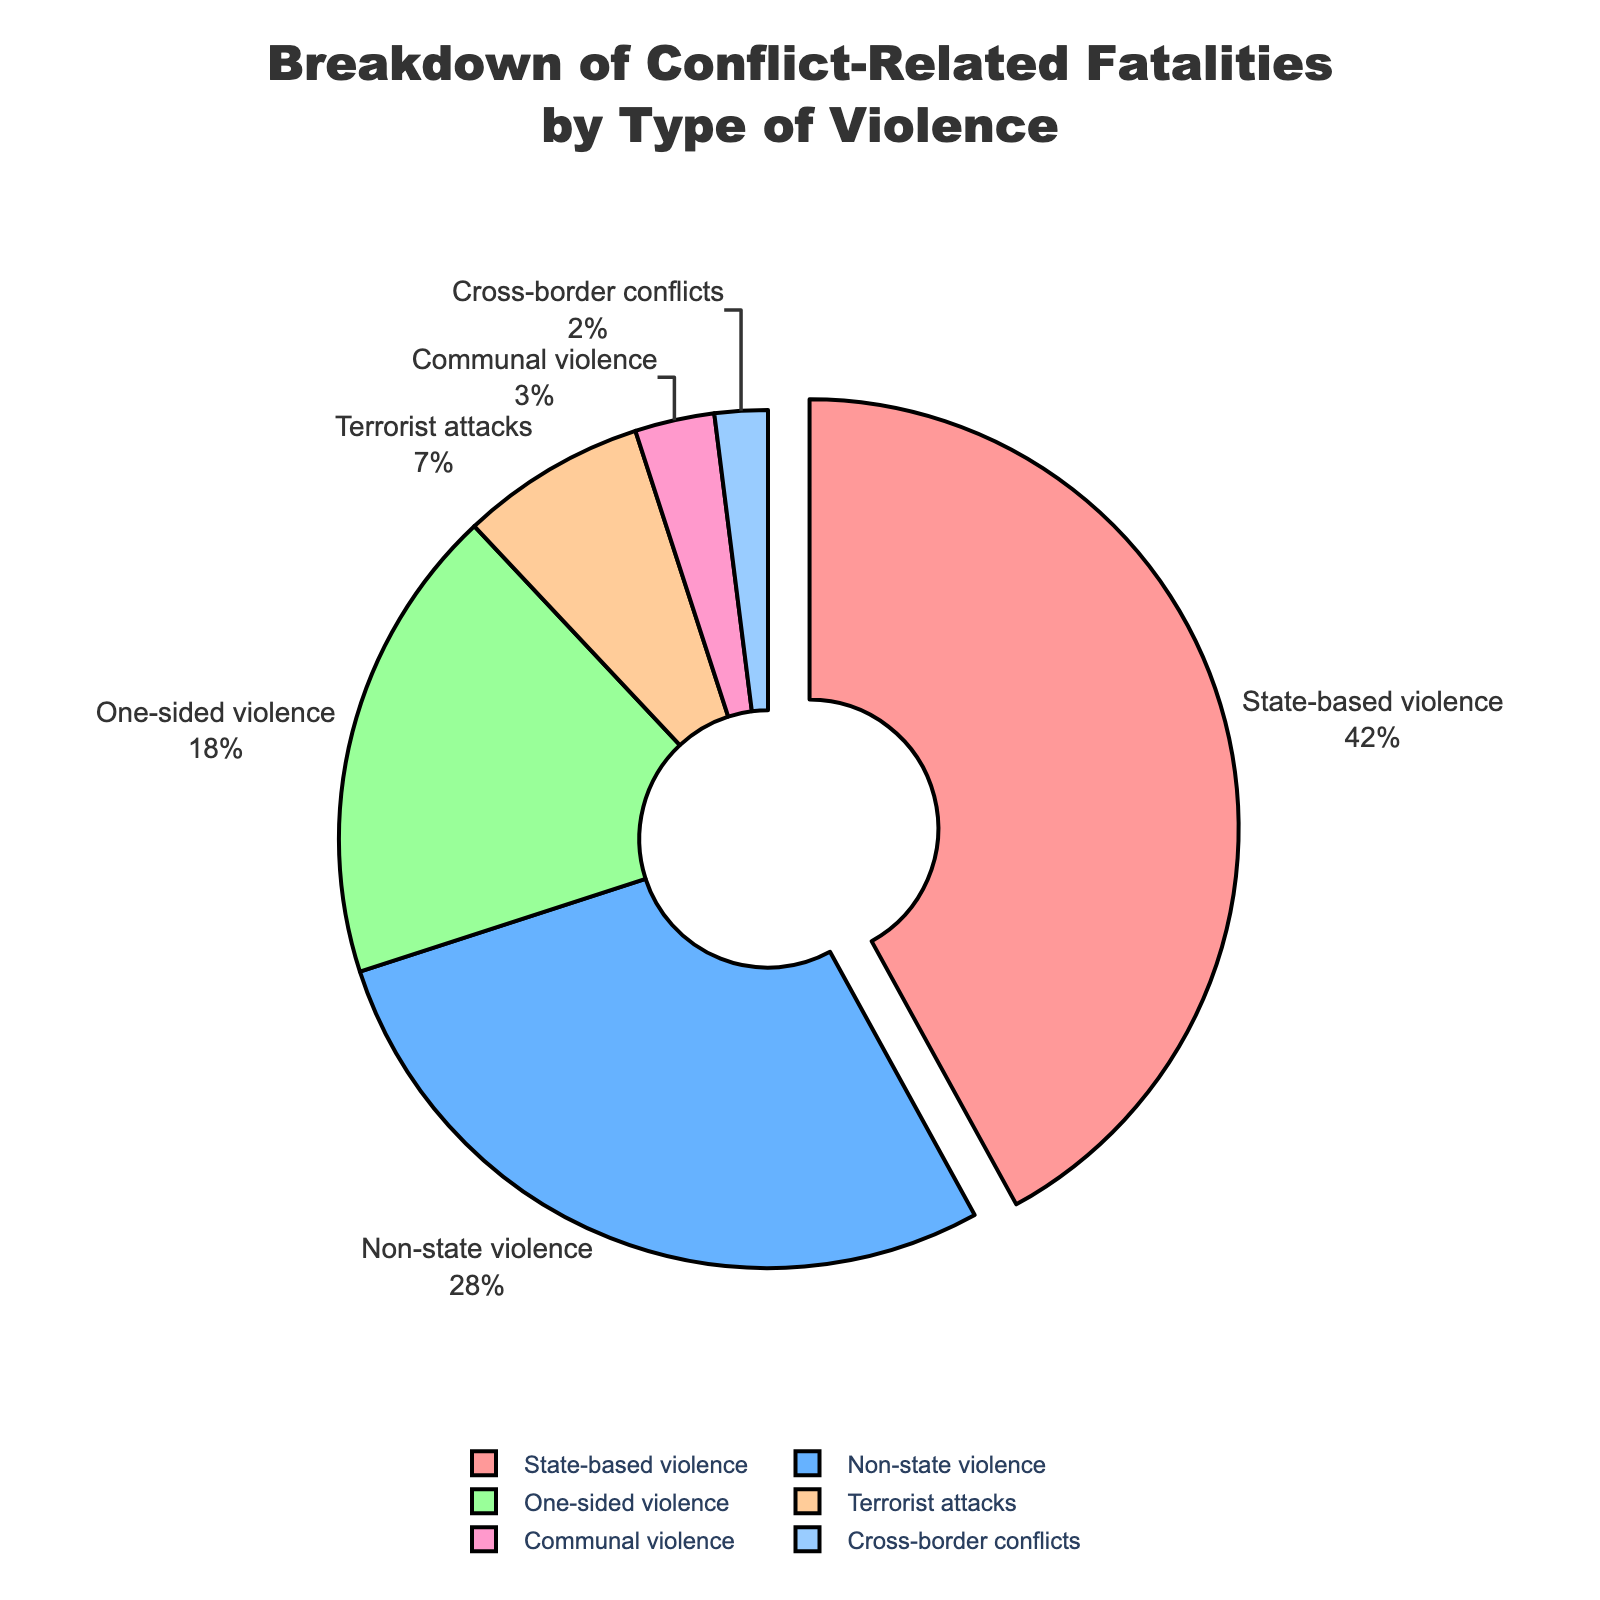Which type of violence accounts for the largest percentage of conflict-related fatalities? The largest type of violence can be identified by looking at the segment with the highest percentage. In this pie chart, state-based violence has the highest percentage.
Answer: State-based violence What is the combined percentage of fatalities from non-state violence and one-sided violence? To find the combined percentage, sum the percentages of non-state violence and one-sided violence (28% and 18%, respectively). 28% + 18% = 46%
Answer: 46% How much larger in percentage is state-based violence compared to terrorist attacks? To determine the difference, subtract the percentage of terrorist attacks from the percentage of state-based violence (42% - 7%). So, 42% - 7% = 35%
Answer: 35% Which type of violence is represented by the color green in the pie chart? The color green corresponds to one of the segments, using the provided color list. The green color is the third in the sequence and represents one-sided violence as per the given order.
Answer: One-sided violence How do the percentages of fatalities from communal violence and cross-border conflicts compare? Look at the chart for the segments representing communal violence and cross-border conflicts. Communal violence is 3% and cross-border conflicts are 2%. Therefore, communal violence has a higher percentage.
Answer: Communal violence has a higher percentage What is the total percentage of fatalities caused by terrorist attacks, communal violence, and cross-border conflicts combined? Add up the individual percentages from terrorist attacks, communal violence, and cross-border conflicts (7%, 3%, and 2%). 7% + 3% + 2% = 12%
Answer: 12% Which type of violence is distinguished by the largest separation or 'pull' effect in the pie chart? The type of violence with the largest percentage is often distinguished by a pull effect. State-based violence accounts for 42%, the largest, thus it has the pull effect.
Answer: State-based violence Is the percentage of fatalities from state-based violence greater than the combined percentages of communal violence and cross-border conflicts? Compare the percentage of state-based violence (42%) with the combined percentages of communal violence and cross-border conflicts (3% + 2% = 5%). 42% > 5%
Answer: Yes What percentage of conflict-related fatalities are not due to state-based or non-state violence? To find this, subtract the combined percentages of state-based and non-state violence from 100% (100% - 42% - 28%). 100% - 42% - 28% = 30%
Answer: 30% Between one-sided violence and terrorist attacks, which has a higher percentage, and by how much? Compare the percentages of one-sided violence (18%) and terrorist attacks (7%), then find the difference (18% - 7%). 18% - 7% = 11%
Answer: One-sided violence by 11% 